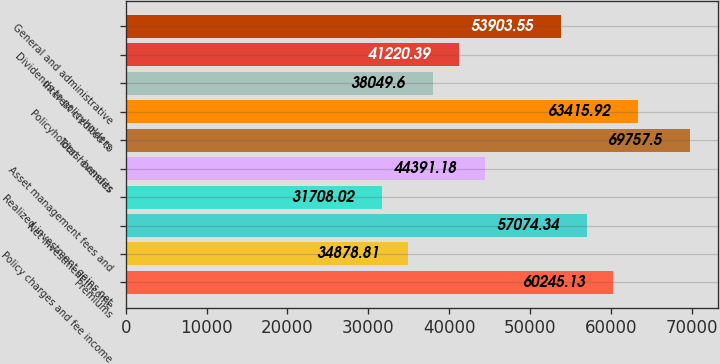Convert chart. <chart><loc_0><loc_0><loc_500><loc_500><bar_chart><fcel>Premiums<fcel>Policy charges and fee income<fcel>Net investment income<fcel>Realized investment gains net<fcel>Asset management fees and<fcel>Total revenues<fcel>Policyholders' benefits<fcel>Interest credited to<fcel>Dividends to policyholders<fcel>General and administrative<nl><fcel>60245.1<fcel>34878.8<fcel>57074.3<fcel>31708<fcel>44391.2<fcel>69757.5<fcel>63415.9<fcel>38049.6<fcel>41220.4<fcel>53903.6<nl></chart> 